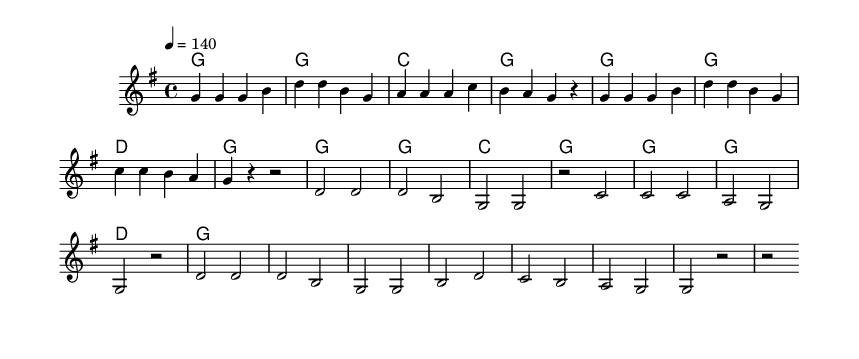What is the key signature of this music? The key signature indicated at the beginning shows one sharp (F#), which is characteristic of G major.
Answer: G major What is the time signature of this piece? The time signature is represented as 4/4, indicating that there are four beats per measure and the quarter note gets one beat.
Answer: 4/4 What is the tempo marking for this music? The tempo marking indicates a speed of 140 beats per minute, as shown in the score.
Answer: 140 How many measures are in the verse? By counting the measures labeled in the verse section, there are a total of eight measures.
Answer: Eight What is the first note of the chorus? Looking at the melody, the first note of the chorus is D, which appears at the beginning of that section.
Answer: D What lyrical theme is presented in the chorus? The theme of the chorus centers around the excitement and energy of wrestling, specifically mentioning "crowd roar" and "bodies flying."
Answer: Crowd roar How many chords are used in the verse section? Observing the chord structure in the verse, there are four different chords represented: G, C, and D, with some repetitions.
Answer: Three 